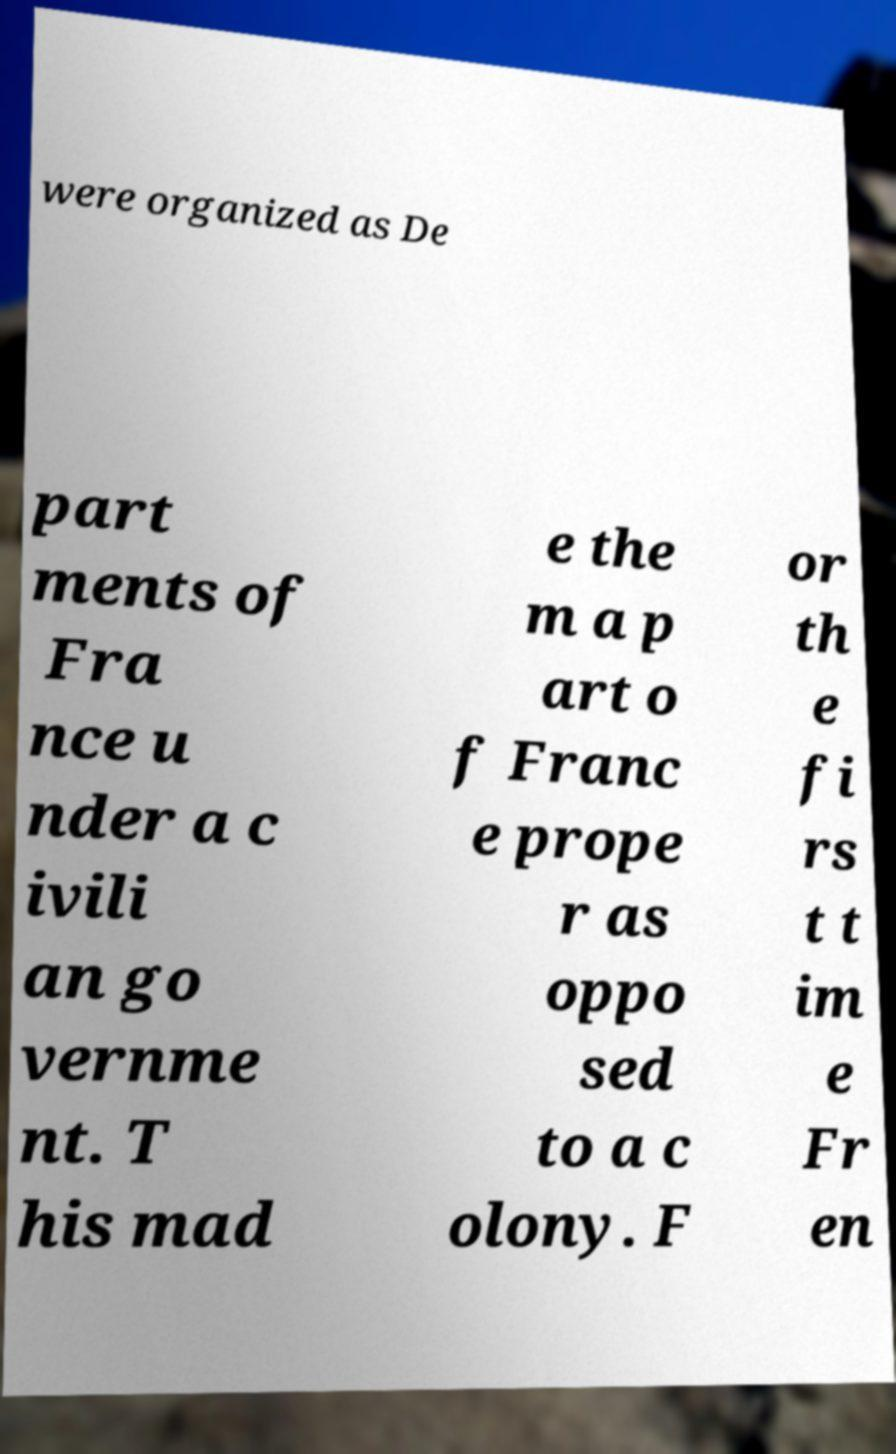Please identify and transcribe the text found in this image. were organized as De part ments of Fra nce u nder a c ivili an go vernme nt. T his mad e the m a p art o f Franc e prope r as oppo sed to a c olony. F or th e fi rs t t im e Fr en 